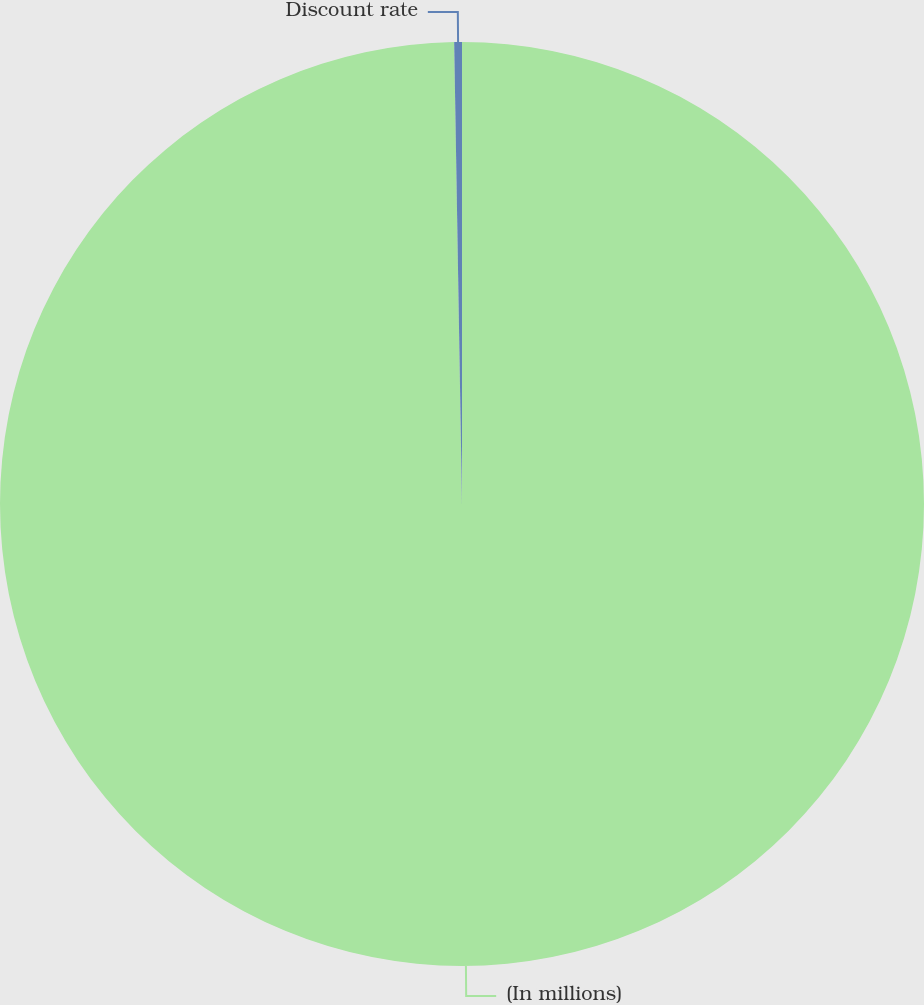Convert chart to OTSL. <chart><loc_0><loc_0><loc_500><loc_500><pie_chart><fcel>(In millions)<fcel>Discount rate<nl><fcel>99.73%<fcel>0.27%<nl></chart> 